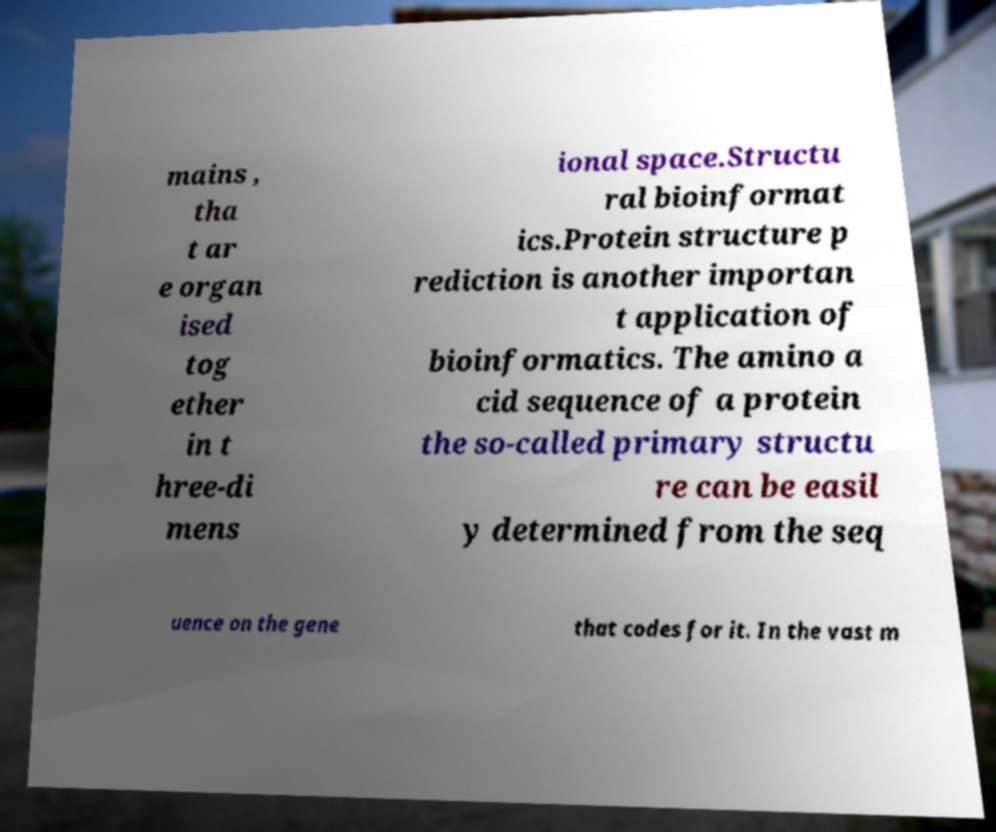Could you assist in decoding the text presented in this image and type it out clearly? mains , tha t ar e organ ised tog ether in t hree-di mens ional space.Structu ral bioinformat ics.Protein structure p rediction is another importan t application of bioinformatics. The amino a cid sequence of a protein the so-called primary structu re can be easil y determined from the seq uence on the gene that codes for it. In the vast m 